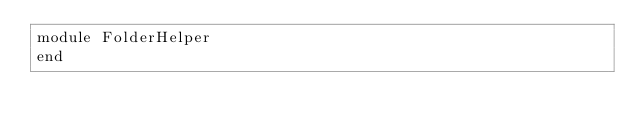<code> <loc_0><loc_0><loc_500><loc_500><_Ruby_>module FolderHelper
end
</code> 